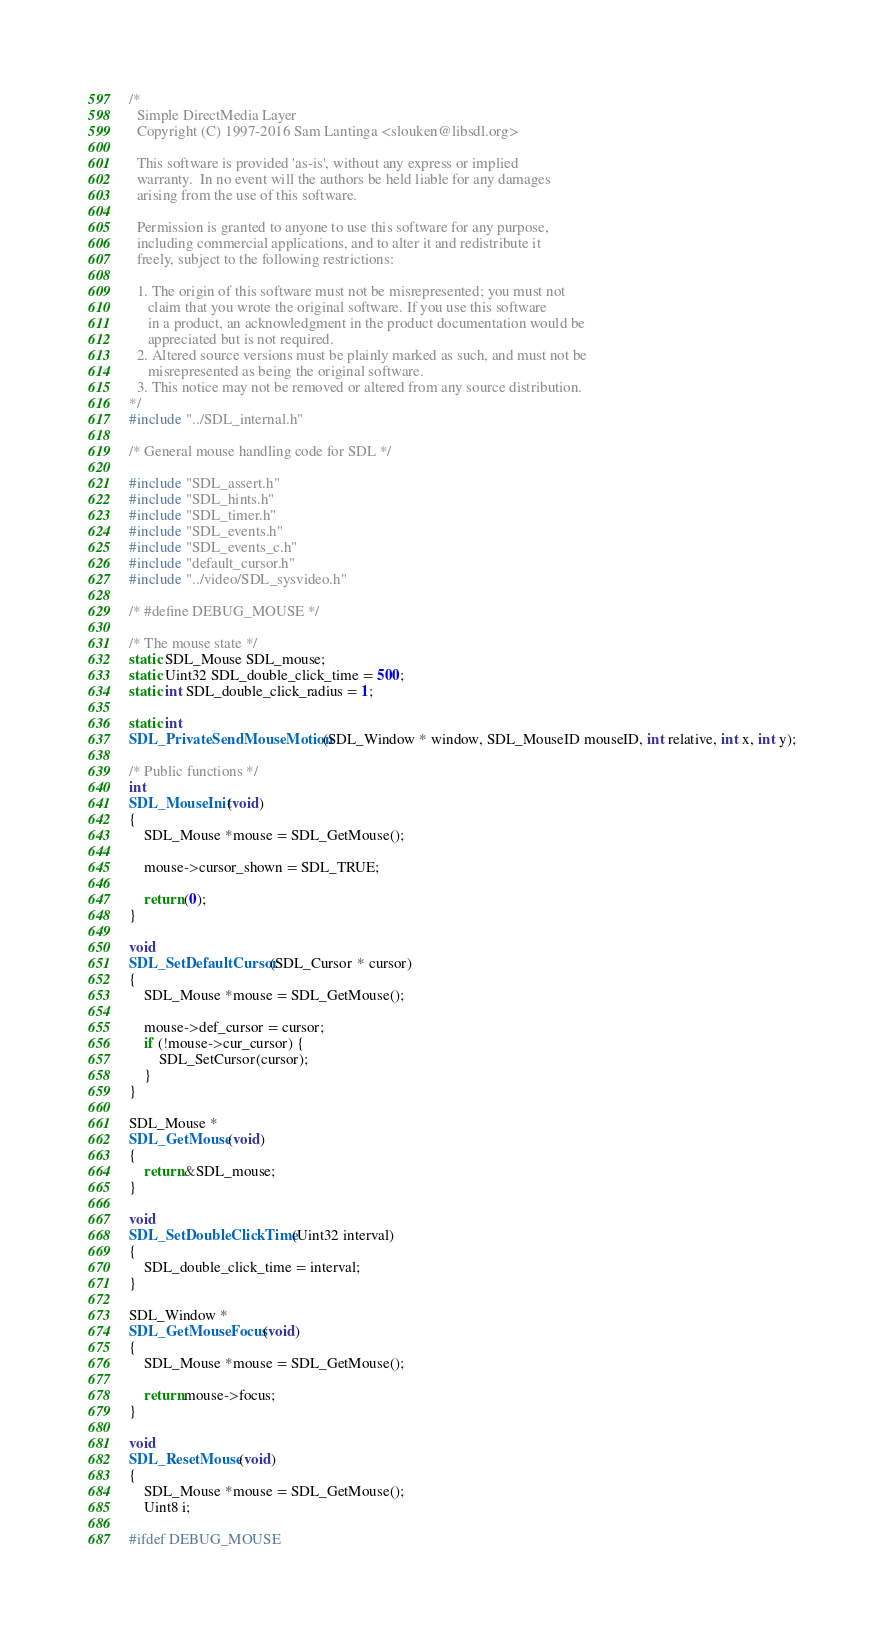<code> <loc_0><loc_0><loc_500><loc_500><_C_>/*
  Simple DirectMedia Layer
  Copyright (C) 1997-2016 Sam Lantinga <slouken@libsdl.org>

  This software is provided 'as-is', without any express or implied
  warranty.  In no event will the authors be held liable for any damages
  arising from the use of this software.

  Permission is granted to anyone to use this software for any purpose,
  including commercial applications, and to alter it and redistribute it
  freely, subject to the following restrictions:

  1. The origin of this software must not be misrepresented; you must not
     claim that you wrote the original software. If you use this software
     in a product, an acknowledgment in the product documentation would be
     appreciated but is not required.
  2. Altered source versions must be plainly marked as such, and must not be
     misrepresented as being the original software.
  3. This notice may not be removed or altered from any source distribution.
*/
#include "../SDL_internal.h"

/* General mouse handling code for SDL */

#include "SDL_assert.h"
#include "SDL_hints.h"
#include "SDL_timer.h"
#include "SDL_events.h"
#include "SDL_events_c.h"
#include "default_cursor.h"
#include "../video/SDL_sysvideo.h"

/* #define DEBUG_MOUSE */

/* The mouse state */
static SDL_Mouse SDL_mouse;
static Uint32 SDL_double_click_time = 500;
static int SDL_double_click_radius = 1;

static int
SDL_PrivateSendMouseMotion(SDL_Window * window, SDL_MouseID mouseID, int relative, int x, int y);

/* Public functions */
int
SDL_MouseInit(void)
{
    SDL_Mouse *mouse = SDL_GetMouse();

    mouse->cursor_shown = SDL_TRUE;

    return (0);
}

void
SDL_SetDefaultCursor(SDL_Cursor * cursor)
{
    SDL_Mouse *mouse = SDL_GetMouse();

    mouse->def_cursor = cursor;
    if (!mouse->cur_cursor) {
        SDL_SetCursor(cursor);
    }
}

SDL_Mouse *
SDL_GetMouse(void)
{
    return &SDL_mouse;
}

void
SDL_SetDoubleClickTime(Uint32 interval)
{
    SDL_double_click_time = interval;
}

SDL_Window *
SDL_GetMouseFocus(void)
{
    SDL_Mouse *mouse = SDL_GetMouse();

    return mouse->focus;
}

void
SDL_ResetMouse(void)
{
    SDL_Mouse *mouse = SDL_GetMouse();
    Uint8 i;

#ifdef DEBUG_MOUSE</code> 